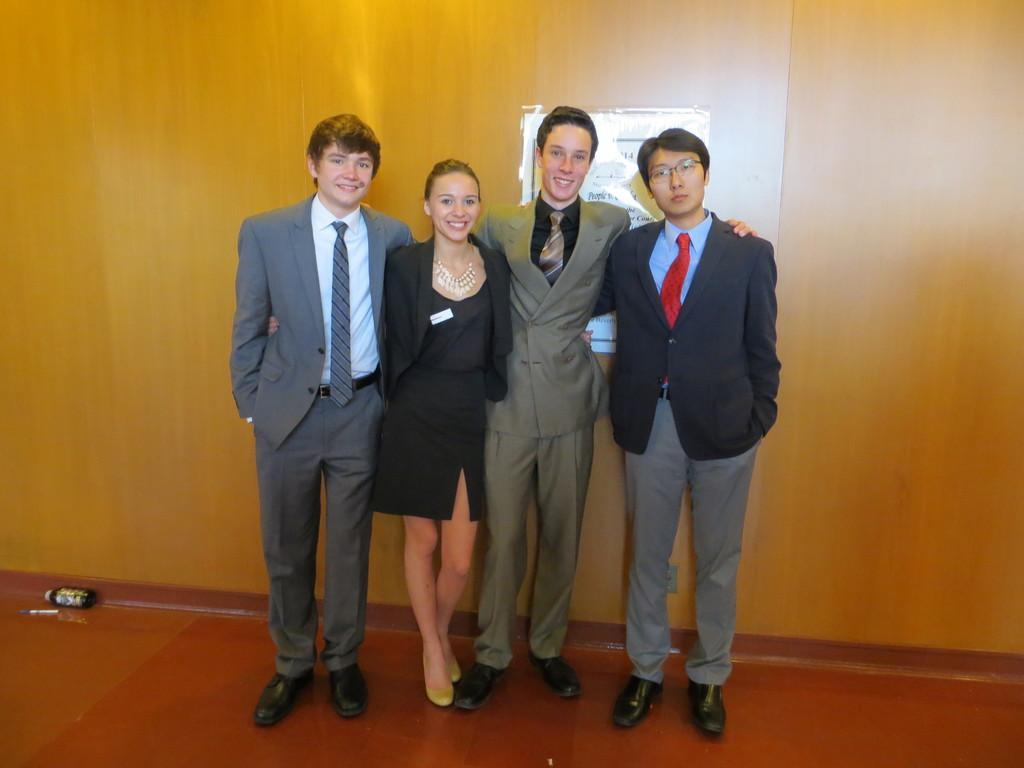Describe this image in one or two sentences. In this picture I can see few people are standing and I can see a poster in the back with some text and I can see men wore coats and ties. 